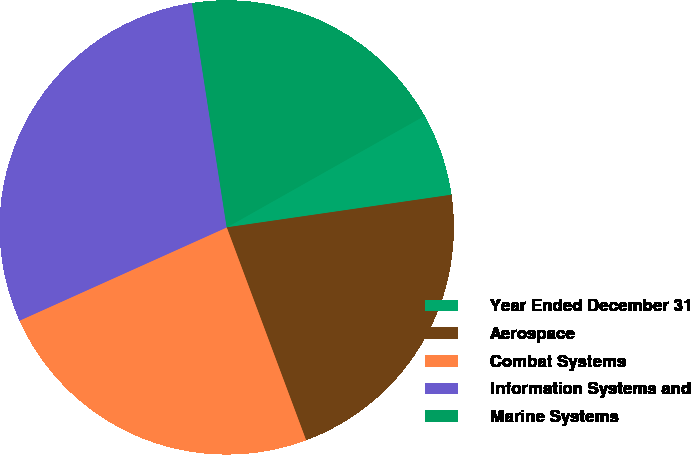<chart> <loc_0><loc_0><loc_500><loc_500><pie_chart><fcel>Year Ended December 31<fcel>Aerospace<fcel>Combat Systems<fcel>Information Systems and<fcel>Marine Systems<nl><fcel>5.88%<fcel>21.61%<fcel>23.95%<fcel>29.28%<fcel>19.27%<nl></chart> 